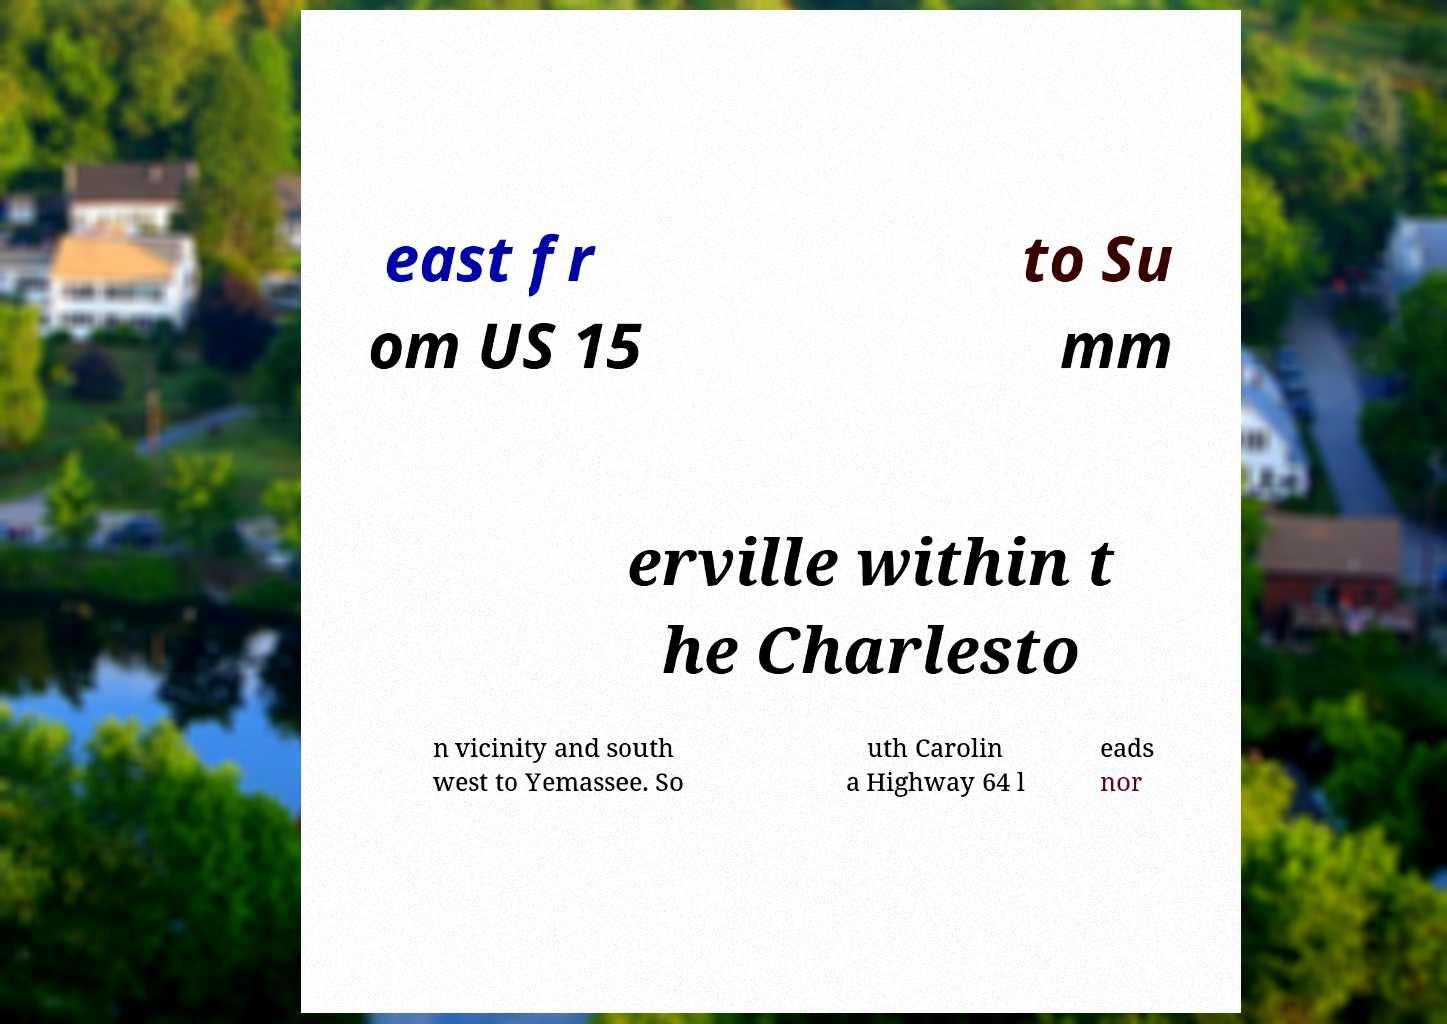Could you assist in decoding the text presented in this image and type it out clearly? east fr om US 15 to Su mm erville within t he Charlesto n vicinity and south west to Yemassee. So uth Carolin a Highway 64 l eads nor 